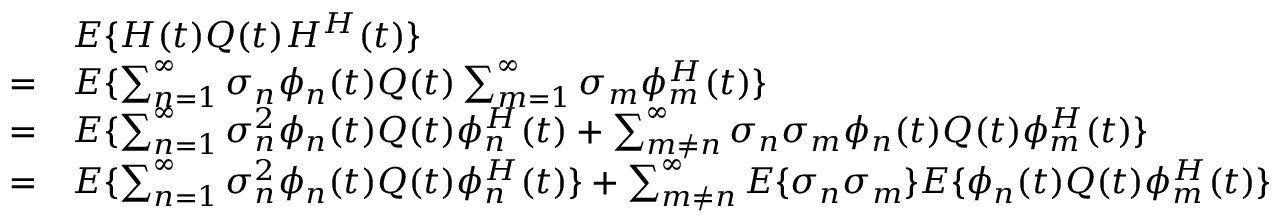Convert formula to latex. <formula><loc_0><loc_0><loc_500><loc_500>\begin{array} { r l } & { E \{ H ( t ) Q ( t ) H ^ { H } ( t ) \} } \\ { = } & { E \{ \sum _ { n = 1 } ^ { \infty } \sigma _ { n } \phi _ { n } ( t ) Q ( t ) \sum _ { m = 1 } ^ { \infty } \sigma _ { m } \phi _ { m } ^ { H } ( t ) \} } \\ { = } & { E \{ \sum _ { n = 1 } ^ { \infty } \sigma _ { n } ^ { 2 } \phi _ { n } ( t ) Q ( t ) \phi _ { n } ^ { H } ( t ) + \sum _ { m \neq n } ^ { \infty } \sigma _ { n } \sigma _ { m } \phi _ { n } ( t ) Q ( t ) \phi _ { m } ^ { H } ( t ) \} } \\ { = } & { E \{ \sum _ { n = 1 } ^ { \infty } \sigma _ { n } ^ { 2 } \phi _ { n } ( t ) Q ( t ) \phi _ { n } ^ { H } ( t ) \} + \sum _ { m \neq n } ^ { \infty } E \{ \sigma _ { n } \sigma _ { m } \} E \{ \phi _ { n } ( t ) Q ( t ) \phi _ { m } ^ { H } ( t ) \} } \end{array}</formula> 